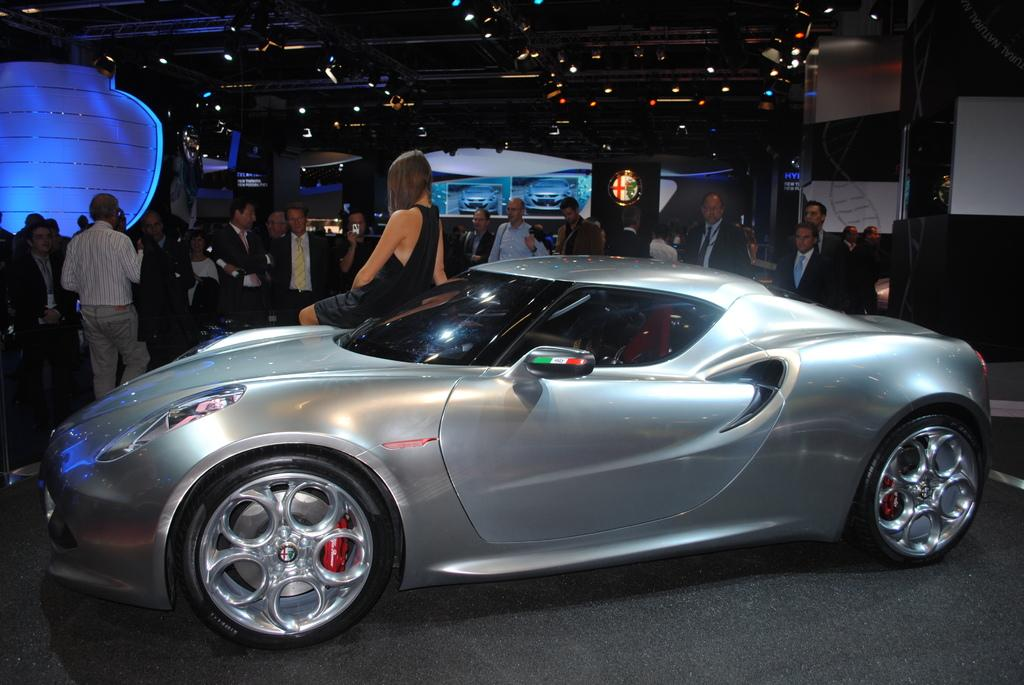What is the person in the image doing? There is a person sitting on a car in the image. Are there any other people in the image? Yes, there are other persons standing in the image. What can be seen attached to the ceiling in the image? There are lights attached to the ceiling in the image. What type of wrench is being used by the person sitting on the car in the image? There is no wrench visible in the image; the person is simply sitting on the car. 